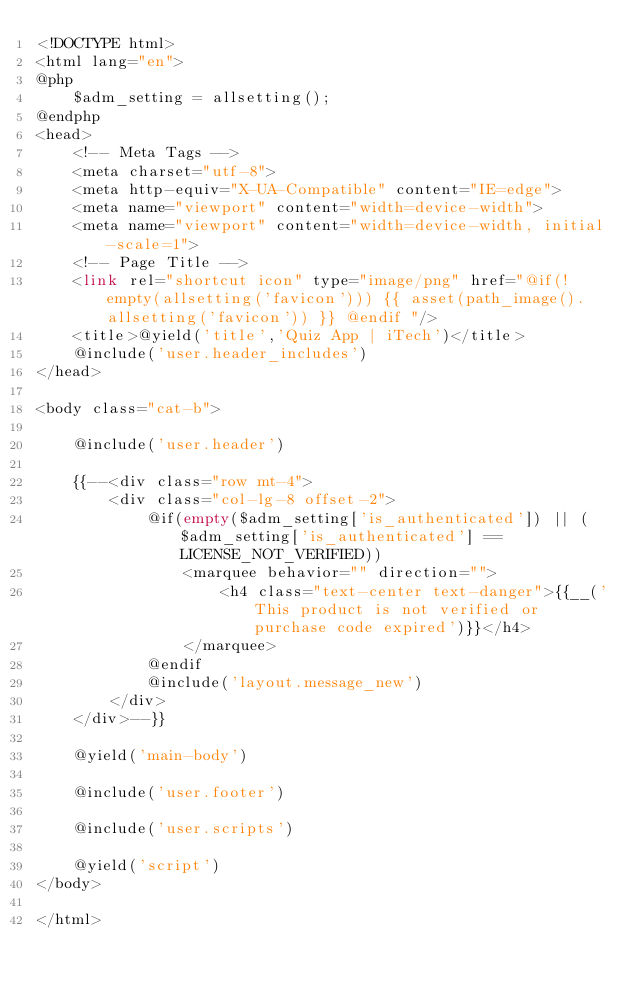Convert code to text. <code><loc_0><loc_0><loc_500><loc_500><_PHP_><!DOCTYPE html>
<html lang="en">
@php
    $adm_setting = allsetting();
@endphp
<head>
    <!-- Meta Tags -->
    <meta charset="utf-8">
    <meta http-equiv="X-UA-Compatible" content="IE=edge">
    <meta name="viewport" content="width=device-width">
    <meta name="viewport" content="width=device-width, initial-scale=1">
    <!-- Page Title -->
    <link rel="shortcut icon" type="image/png" href="@if(!empty(allsetting('favicon'))) {{ asset(path_image().allsetting('favicon')) }} @endif "/>
    <title>@yield('title','Quiz App | iTech')</title>
    @include('user.header_includes')
</head>

<body class="cat-b">

    @include('user.header')

    {{--<div class="row mt-4">
        <div class="col-lg-8 offset-2">
            @if(empty($adm_setting['is_authenticated']) || ($adm_setting['is_authenticated'] == LICENSE_NOT_VERIFIED))
                <marquee behavior="" direction="">
                    <h4 class="text-center text-danger">{{__('This product is not verified or purchase code expired')}}</h4>
                </marquee>
            @endif
            @include('layout.message_new')
        </div>
    </div>--}}

    @yield('main-body')

    @include('user.footer')

    @include('user.scripts')

    @yield('script')
</body>

</html></code> 